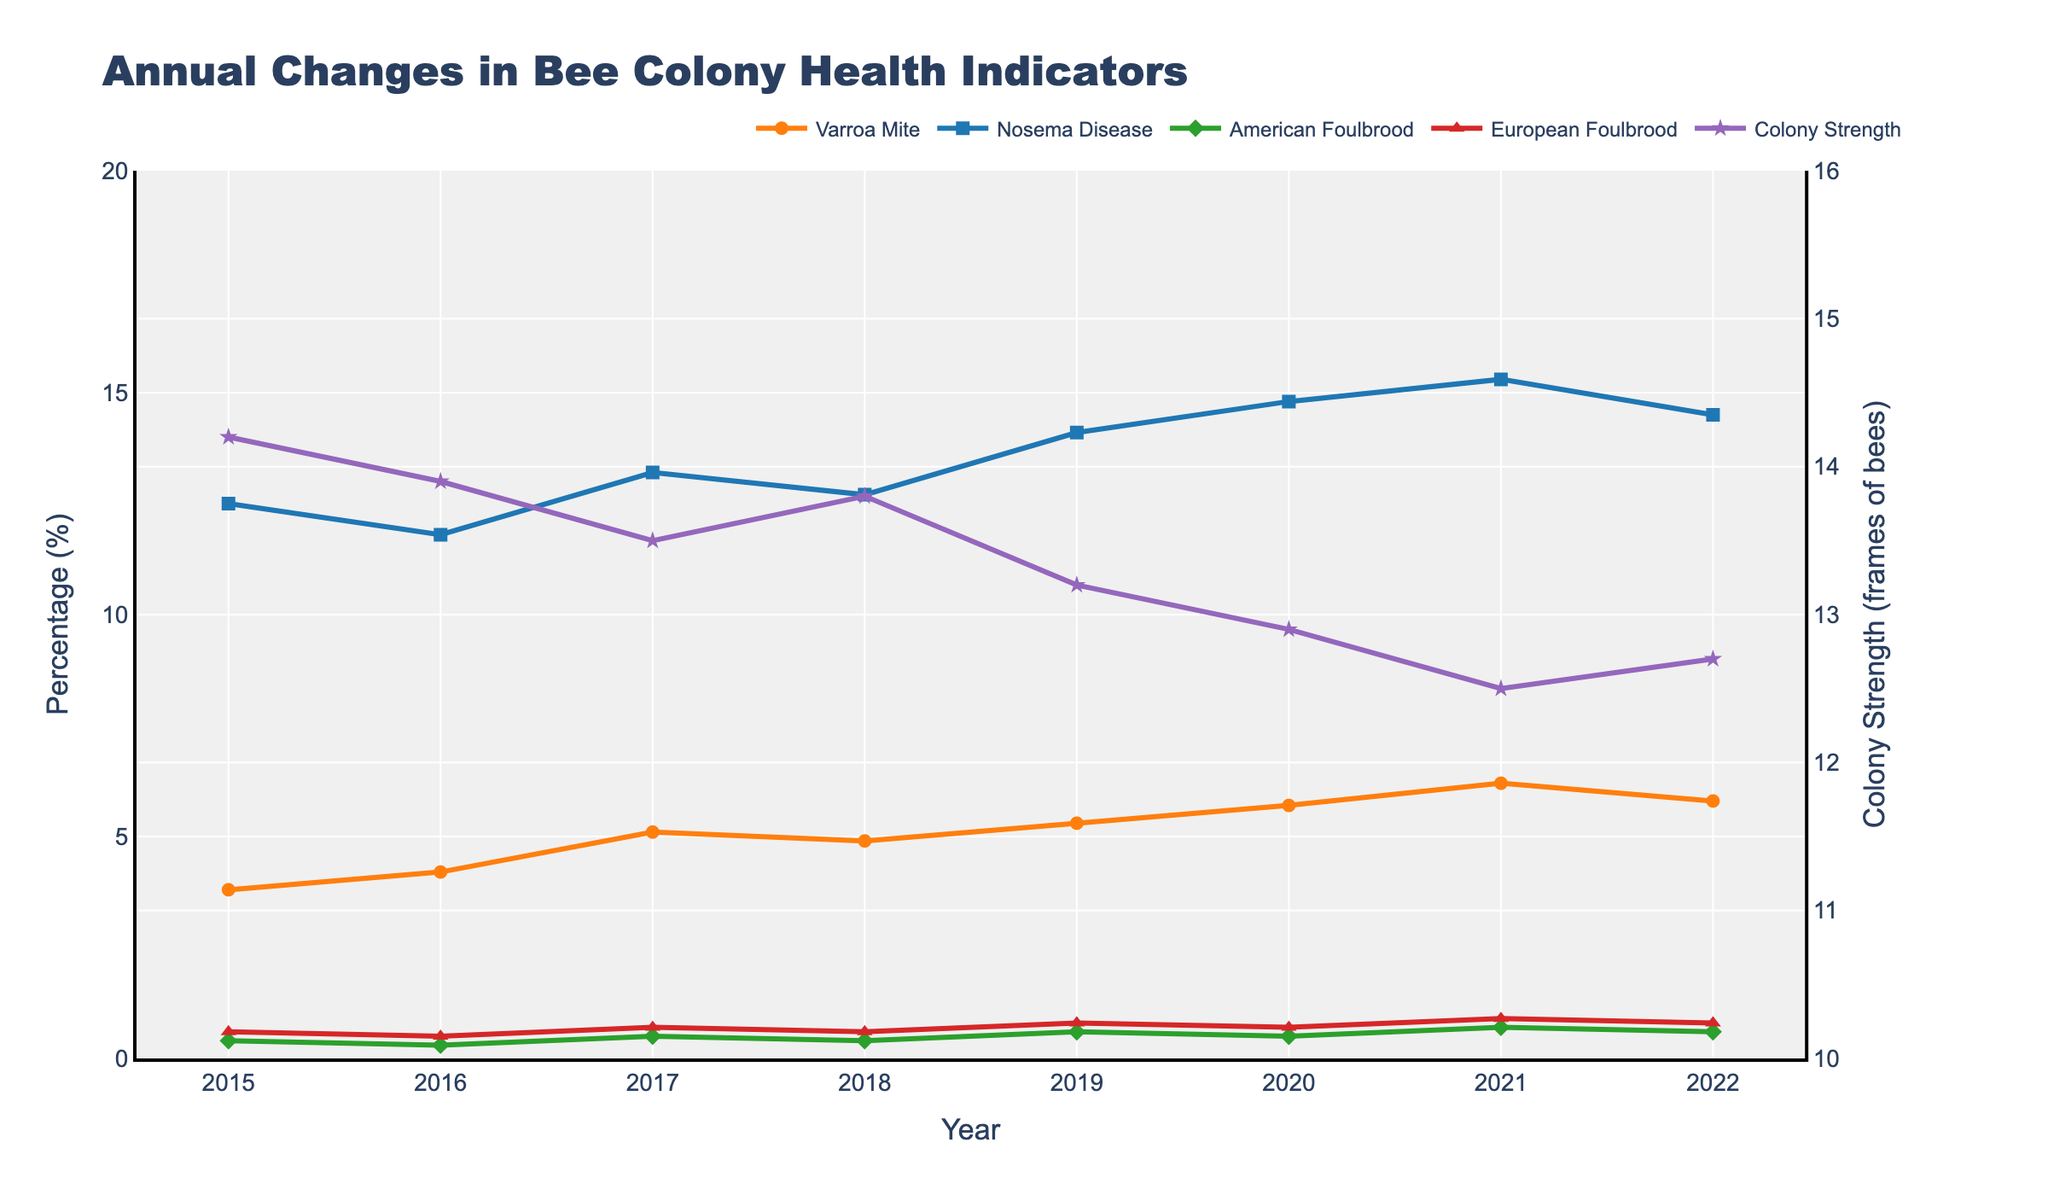Which year had the highest Varroa Mite Infestation? The Varroa Mite Infestation peaks at 6.2% in 2021. Therefore, 2021 had the highest infestation rate among all the years presented.
Answer: 2021 How did Colony Strength change from 2015 to 2022? Colony strength decreased from 14.2 frames in 2015 to 12.7 frames in 2022. This represents a decline of 1.5 frames of bees over the period.
Answer: Decreased by 1.5 frames Which disease has the highest prevalence in 2022 and by how much? In 2022, Nosema Disease Prevalence is the highest at 14.5%. By comparing it with other diseases' prevalence in 2022, it is evident that it has the highest value among them.
Answer: Nosema Disease at 14.5% What is the overall trend for American Foulbrood Incidence from 2015 to 2022? The trend shows fluctuations, starting at 0.4% in 2015 and peaking at 0.7% in 2021, then returning to 0.6% in 2022, indicating a general increase over time.
Answer: Increasing Compare the Varroa Mite Infestation rates between 2016 and 2020. In 2016, the infestation rate was 4.2%, and in 2020, it increased to 5.7%. Comparing these rates shows that the infestation grew by 1.5 percentage points over this period.
Answer: Increased by 1.5 percentage points Between which consecutive years did Nosema Disease Prevalence see the highest increase? The nosema prevalence jumps from 11.8% in 2016 to 13.2% in 2017, reflecting an increase of 1.4 percentage points, the largest such change across consecutive years.
Answer: 2016 to 2017 What is the range of Colony Strength values over the years? The highest Colony Strength is 14.2 frames in 2015, and the lowest is 12.5 frames in 2021. The range is calculated by subtracting the smallest value from the largest: 14.2 - 12.5 = 1.7 frames.
Answer: 1.7 frames By how much did the European Foulbrood Incidence increase from 2015 to 2021? European Foulbrood Incidence increased from 0.6% in 2015 to 0.9% in 2021. This increment is calculated as 0.9 - 0.6 = 0.3 percentage points.
Answer: 0.3 percentage points In which year did Colony Strength fall below 13 frames for the first time? Observing the chart, Colony Strength first falls below 13 frames in 2020 when it reaches 12.9 frames.
Answer: 2020 Compare the Nosema Disease Prevalence in 2018 and 2019. Nosema Disease Prevalence was 12.7% in 2018 and increased to 14.1% in 2019, indicating a rise of 1.4 percentage points.
Answer: Increased by 1.4 percentage points 